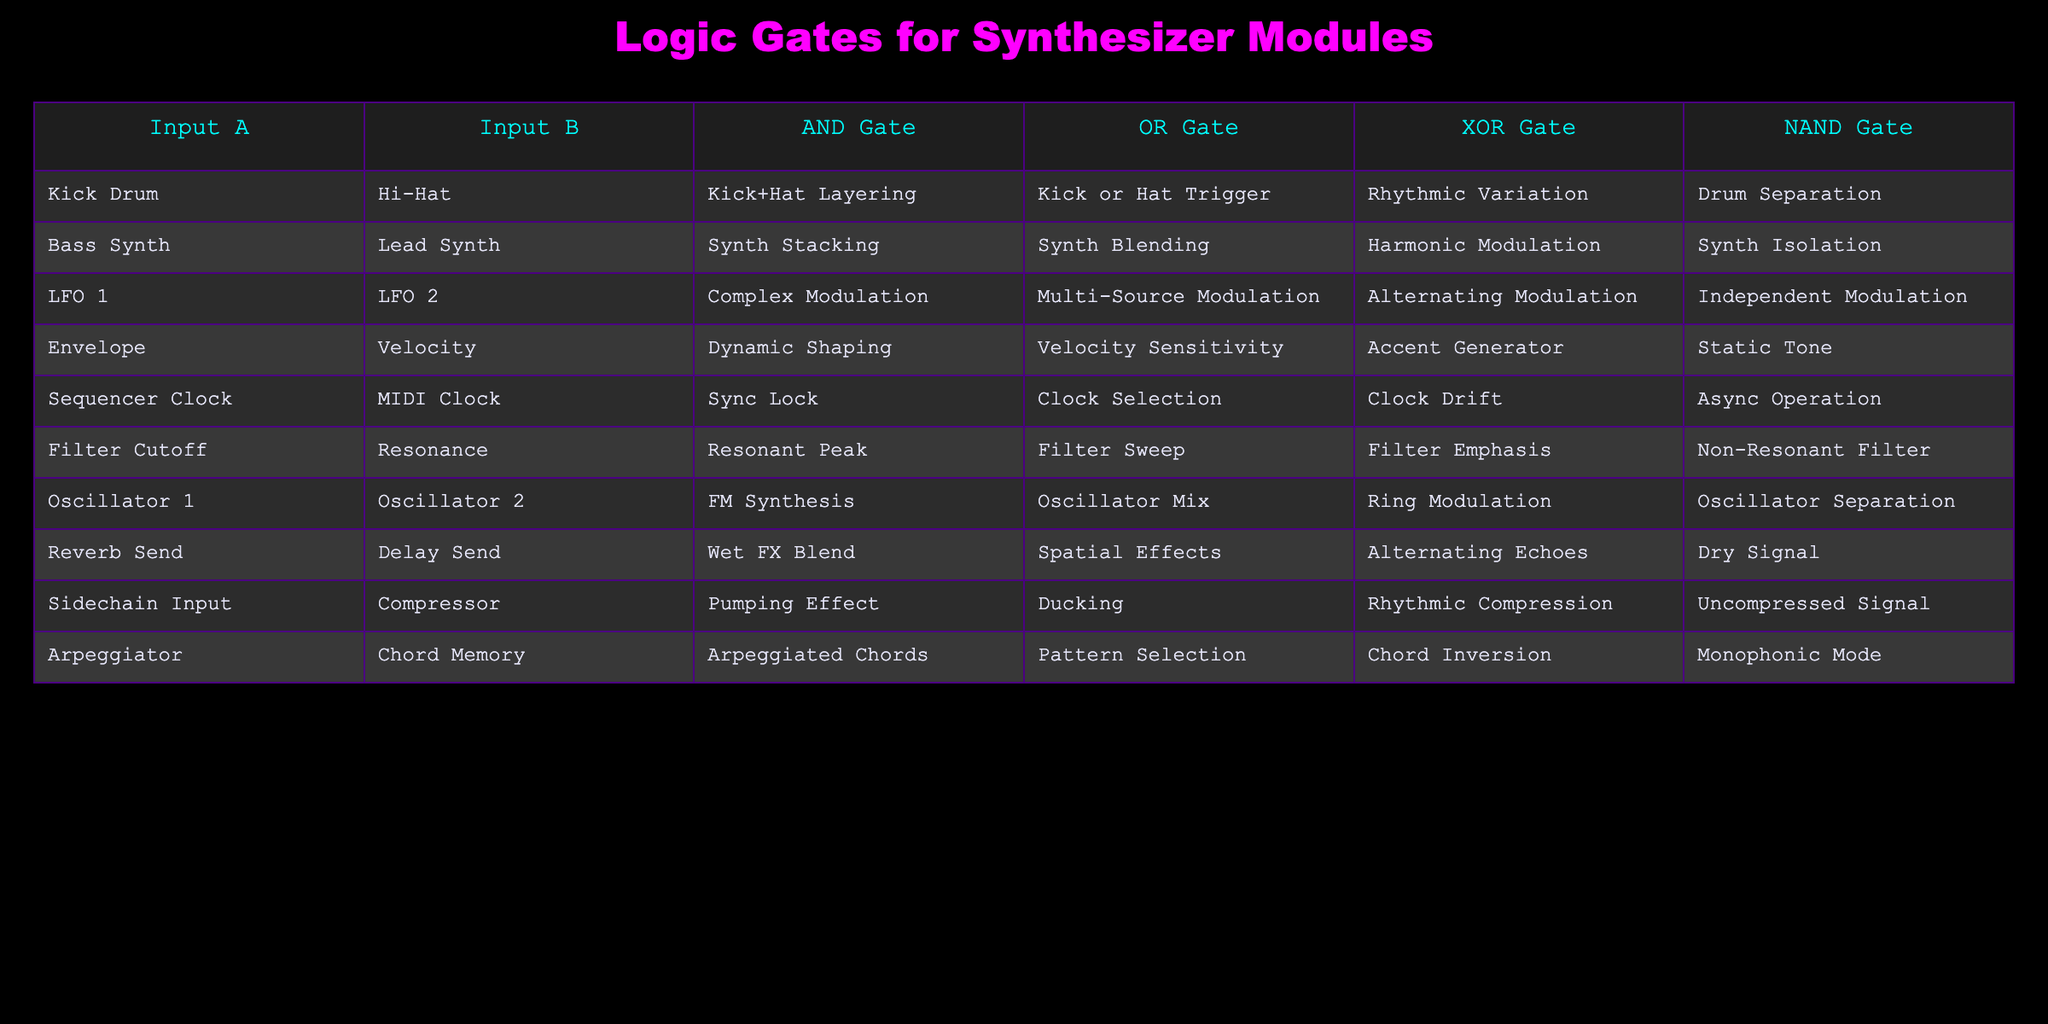What outputs can you achieve from a Kick Drum and Hi-Hat input through the AND Gate? The AND Gate output for Kick Drum and Hi-Hat inputs is "Kick+Hat Layering," indicating that both sounds will be combined if triggered simultaneously.
Answer: Kick+Hat Layering What is the output of the XOR Gate when Bass Synth and Lead Synth are applied? The XOR Gate output for Bass Synth and Lead Synth inputs is "Harmonic Modulation," which suggests that the resulting modulation will only occur when one of the signals is present but not both simultaneously.
Answer: Harmonic Modulation Does the Reverb Send combined with Delay Send create a dry signal according to the NAND Gate? The NAND Gate output for Reverb Send and Delay Send inputs is "Dry Signal," which means the combination of these two sends will not result in a completely dry output. This indicates that it is a false statement.
Answer: No What is the output of the OR Gate when you connect a Sequencer Clock and MIDI Clock? The OR Gate output for the Sequencer Clock and MIDI Clock is "Clock Selection," meaning that either clock can be selected to trigger the device in a versatile manner.
Answer: Clock Selection If you want to achieve both a pumping effect and velocity sensitivity, which inputs should you use with the AND Gate? The AND Gate output for Sidechain Input and Compressor gives you "Pumping Effect," while the Envelope and Velocity gives "Dynamic Shaping." To achieve both effects at once, the necessary inputs would be Sidechain Input and Compressor to produce the pumping effect, combining with Envelope for dynamism but not directly yielding velocity sensitivity. Since there are no direct outputs combining them, we must choose Sidechain and Compressor.
Answer: Sidechain Input and Compressor What happens when you input Envelope and Velocity signals through an OR Gate? The OR Gate output for Envelope and Velocity inputs results in "Velocity Sensitivity," indicating that the presence of either input will affect the response, particularly the dynamic shaping of sound.
Answer: Velocity Sensitivity Can you confirm that combining Filter Cutoff and Resonance outputs through the AND Gate will create a non-resonant filter? The AND Gate for Filter Cutoff and Resonance results in "Resonant Peak," meaning that this combination does not yield a non-resonant filter, thus making the statement false.
Answer: No Which modulation type is achieved through the NAND Gate with LFO 1 and LFO 2 signals? The NAND Gate output for LFO 1 and LFO 2 signals results in "Independent Modulation," indicating that non-connected outputs still yield unique modulation paths, further enhancing sound design versatility.
Answer: Independent Modulation What can you conclude if you combine Arpeggiator and Chord Memory in the context of an XOR Gate? Combining Arpeggiator and Chord Memory outputs through XOR Gate gives "Pattern Selection," meaning only one of the patterns will be selected at a time, enhancing the creativity in programming sequences.
Answer: Pattern Selection 